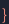<code> <loc_0><loc_0><loc_500><loc_500><_FORTRAN_>
}
</code> 